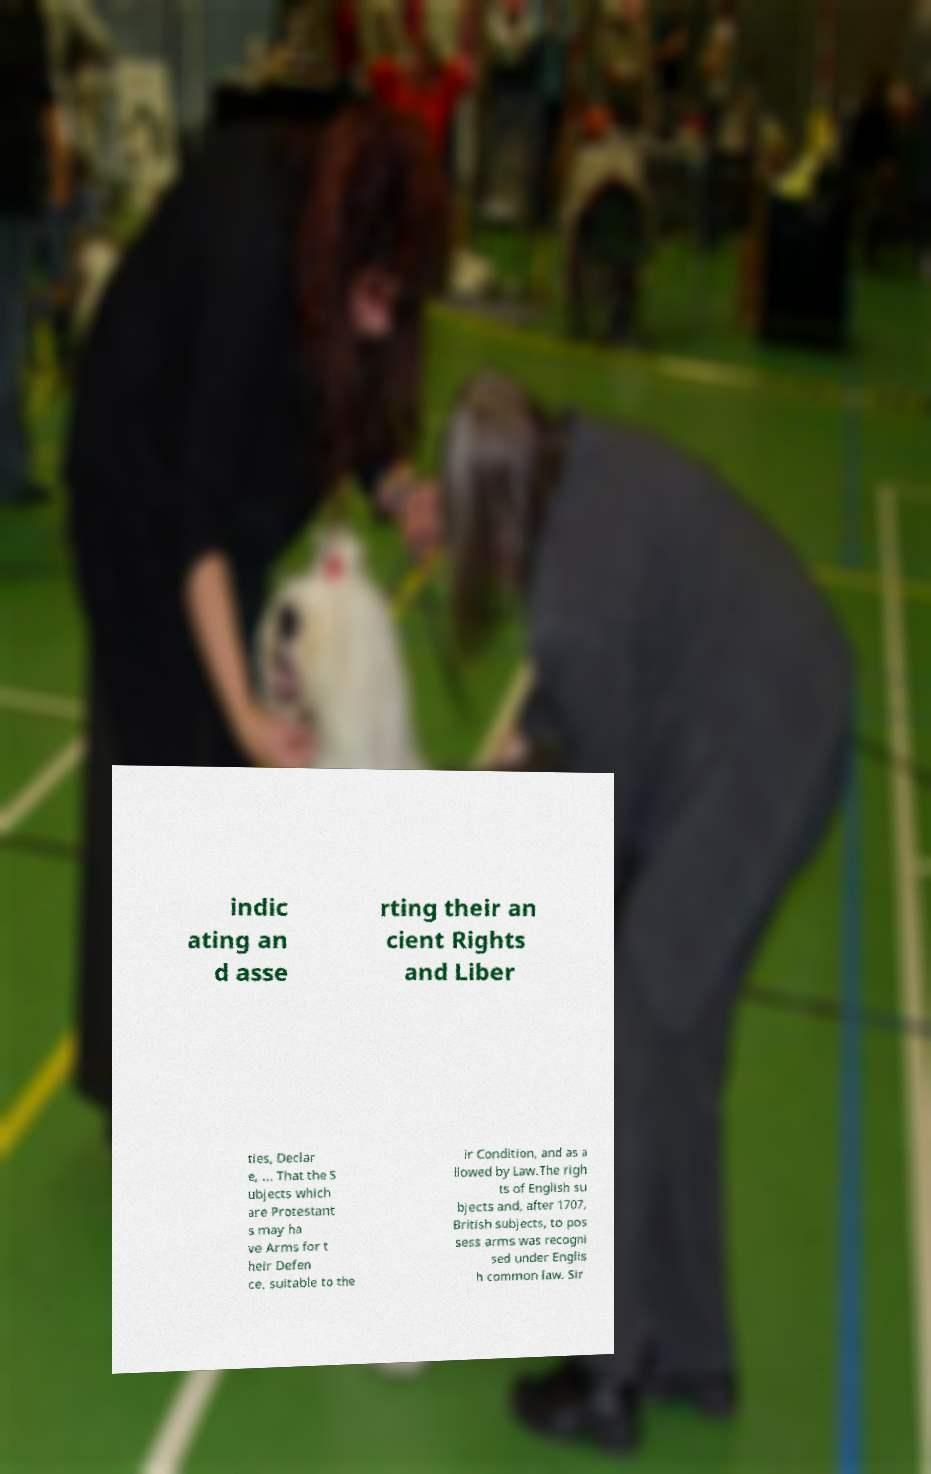Could you extract and type out the text from this image? indic ating an d asse rting their an cient Rights and Liber ties, Declar e, ... That the S ubjects which are Protestant s may ha ve Arms for t heir Defen ce, suitable to the ir Condition, and as a llowed by Law.The righ ts of English su bjects and, after 1707, British subjects, to pos sess arms was recogni sed under Englis h common law. Sir 